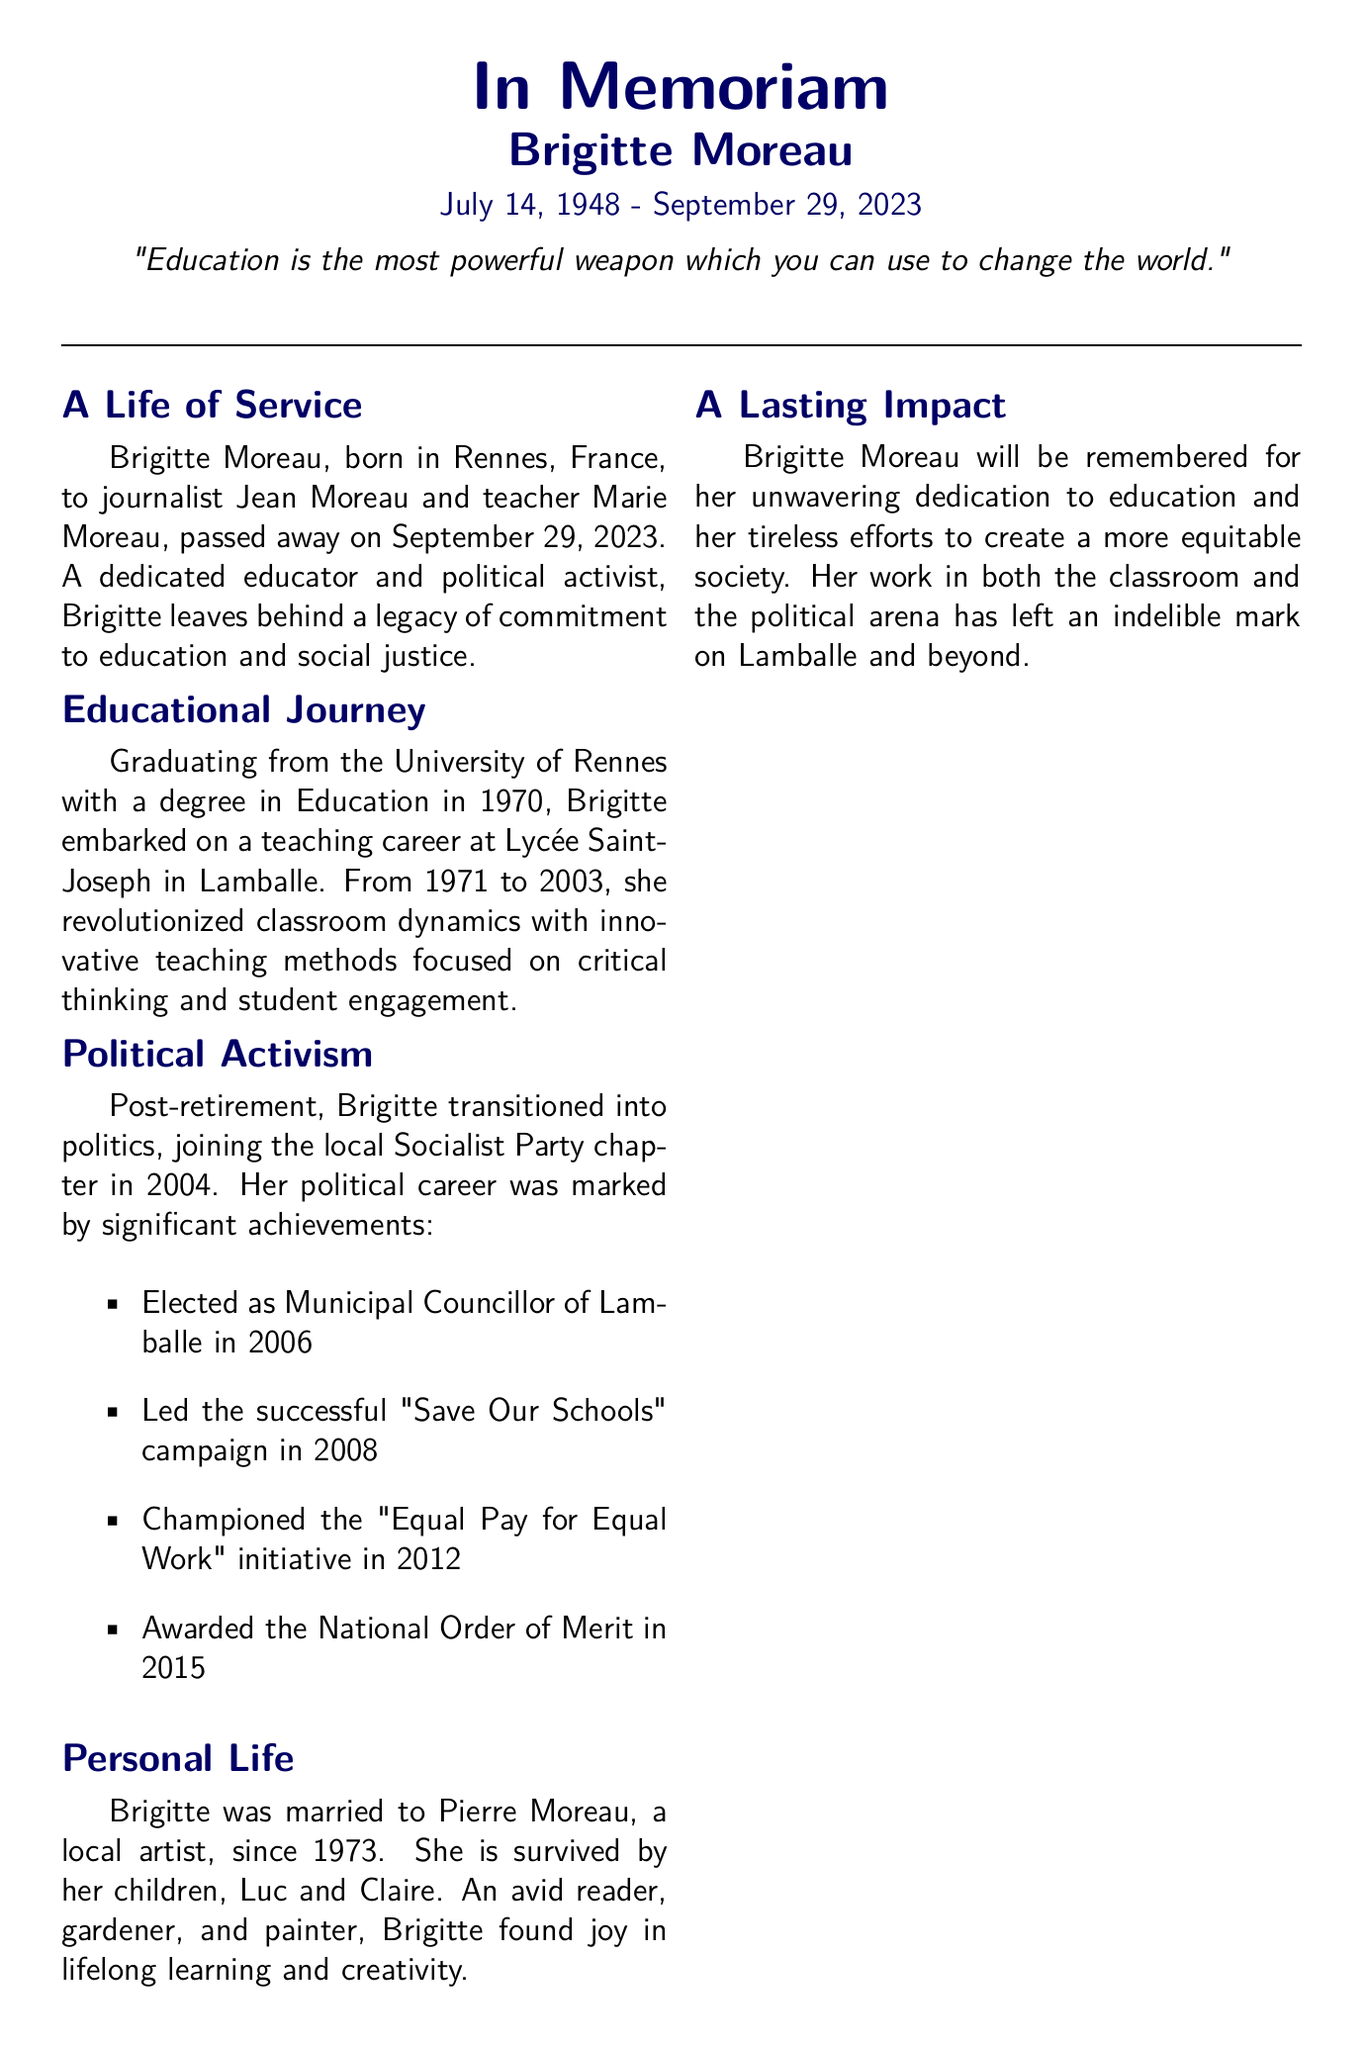What was Brigitte Moreau's date of birth? The document states that Brigitte Moreau was born on July 14, 1948.
Answer: July 14, 1948 When did Brigitte start teaching at Lycée Saint-Joseph? According to the document, Brigitte began her teaching career at Lycée Saint-Joseph in 1971.
Answer: 1971 What political party did Brigitte join in 2004? The document notes that Brigitte joined the local Socialist Party chapter in 2004.
Answer: Socialist Party Which campaign did Brigitte lead in 2008? The document highlights her leadership in the "Save Our Schools" campaign in 2008.
Answer: Save Our Schools How many children did Brigitte have? The document states that Brigitte is survived by her two children, Luc and Claire.
Answer: Two What prestigious award did Brigitte receive in 2015? It is mentioned in the document that she was awarded the National Order of Merit in 2015.
Answer: National Order of Merit What quote is attributed to Brigitte in the document? The document includes the quote, "Education is the most powerful weapon which you can use to change the world."
Answer: "Education is the most powerful weapon which you can use to change the world." In which year did Brigitte pass away? The document states that Brigitte passed away on September 29, 2023.
Answer: September 29, 2023 What was Brigitte's profession before entering politics? The document details that she was a dedicated educator before transitioning into politics.
Answer: Educator 